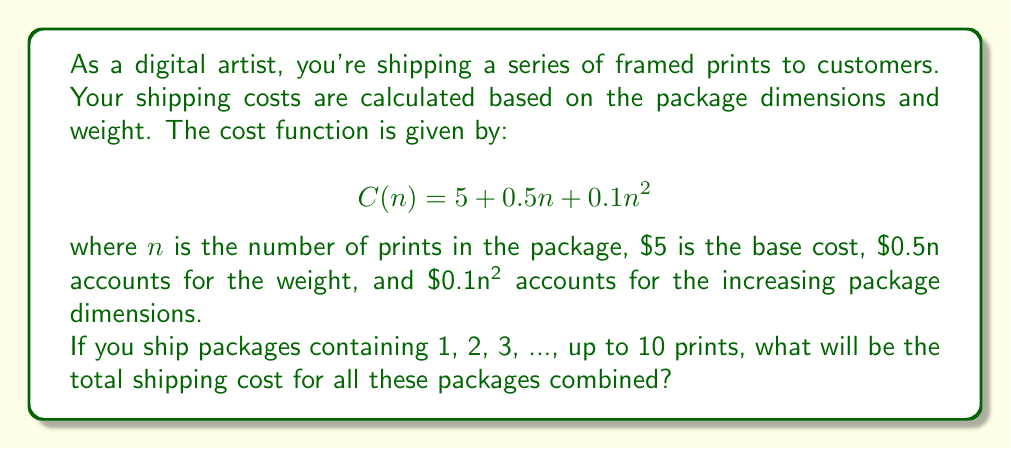Show me your answer to this math problem. To solve this problem, we need to calculate the sum of the shipping costs for packages containing 1 to 10 prints. This can be represented as a series:

$$\sum_{n=1}^{10} C(n) = \sum_{n=1}^{10} (5 + 0.5n + 0.1n^2)$$

Let's break this down into three parts:

1. Constant term: $\sum_{n=1}^{10} 5 = 5 \cdot 10 = 50$

2. Linear term: $\sum_{n=1}^{10} 0.5n = 0.5 \cdot \frac{10(10+1)}{2} = 0.5 \cdot 55 = 27.5$

3. Quadratic term: $\sum_{n=1}^{10} 0.1n^2 = 0.1 \cdot \frac{10(10+1)(2\cdot10+1)}{6} = 0.1 \cdot 385 = 38.5$

Now, we sum these three parts:

$$50 + 27.5 + 38.5 = 116$$

Therefore, the total shipping cost for all packages from 1 to 10 prints is $116.
Answer: $116 